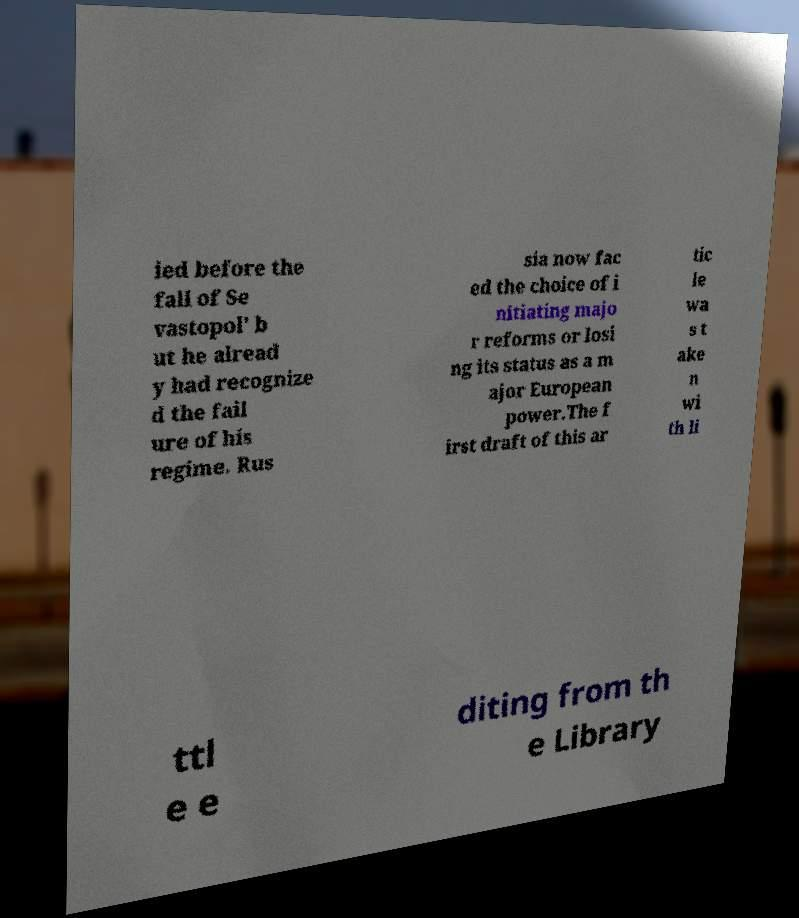What messages or text are displayed in this image? I need them in a readable, typed format. ied before the fall of Se vastopol' b ut he alread y had recognize d the fail ure of his regime. Rus sia now fac ed the choice of i nitiating majo r reforms or losi ng its status as a m ajor European power.The f irst draft of this ar tic le wa s t ake n wi th li ttl e e diting from th e Library 